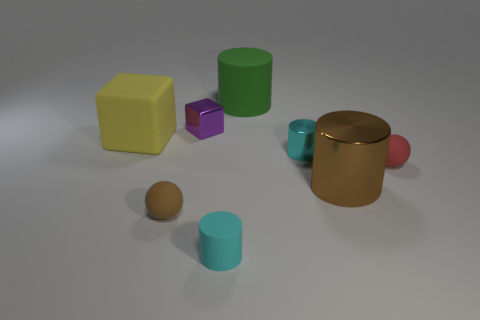What time of the day does the lighting in the image suggest? The lighting in the image is soft and diffuse, lacking harsh shadows or bright highlights, which doesn't strongly suggest a particular time of day but is reminiscent of an overcast sky or indoor lighting conditions often used in product photography. 